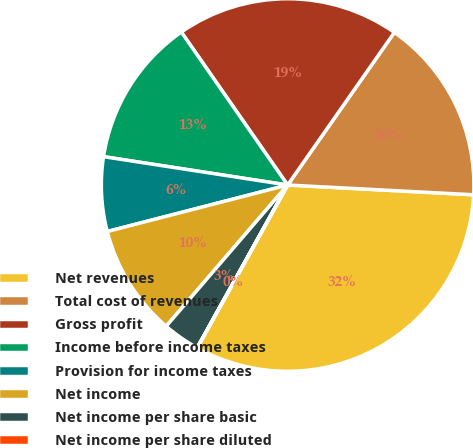<chart> <loc_0><loc_0><loc_500><loc_500><pie_chart><fcel>Net revenues<fcel>Total cost of revenues<fcel>Gross profit<fcel>Income before income taxes<fcel>Provision for income taxes<fcel>Net income<fcel>Net income per share basic<fcel>Net income per share diluted<nl><fcel>32.23%<fcel>16.12%<fcel>19.38%<fcel>12.9%<fcel>6.45%<fcel>9.68%<fcel>3.23%<fcel>0.01%<nl></chart> 